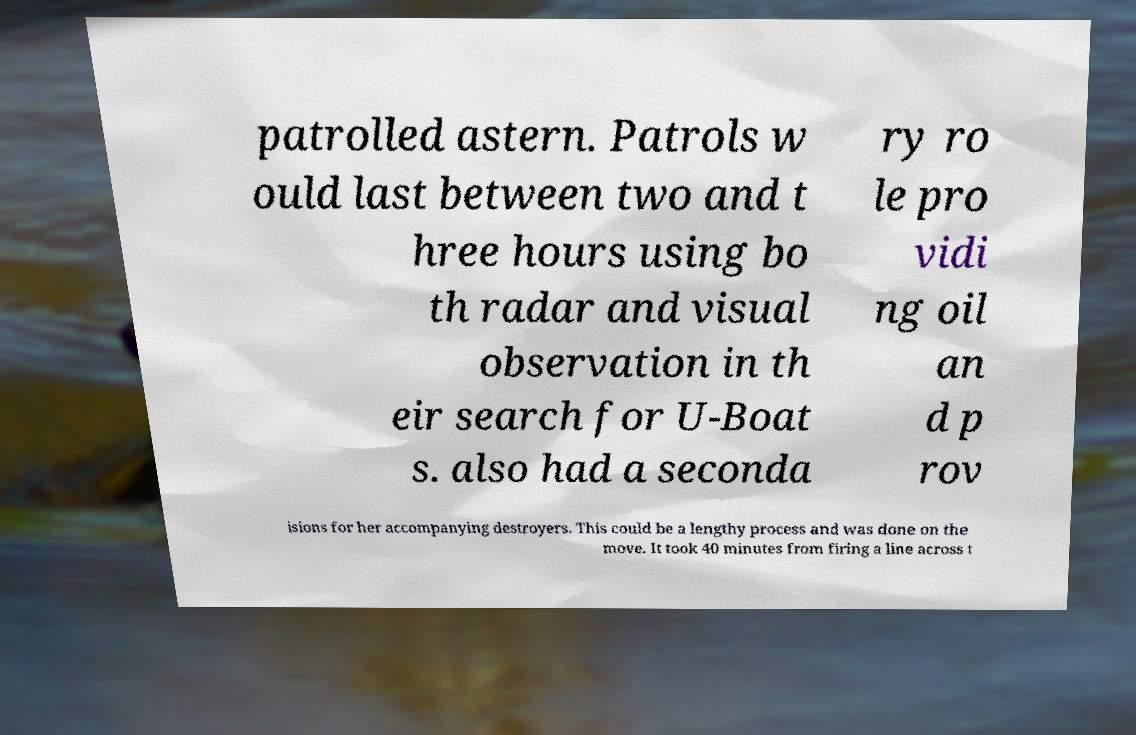What messages or text are displayed in this image? I need them in a readable, typed format. patrolled astern. Patrols w ould last between two and t hree hours using bo th radar and visual observation in th eir search for U-Boat s. also had a seconda ry ro le pro vidi ng oil an d p rov isions for her accompanying destroyers. This could be a lengthy process and was done on the move. It took 40 minutes from firing a line across t 